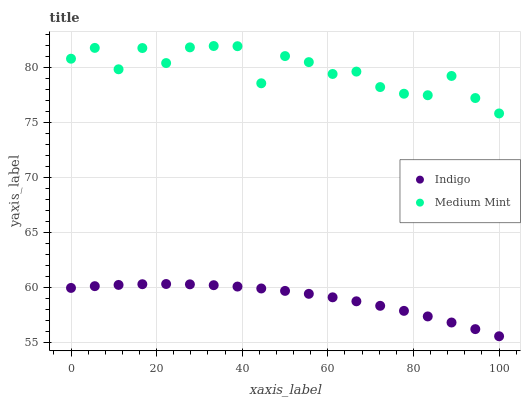Does Indigo have the minimum area under the curve?
Answer yes or no. Yes. Does Medium Mint have the maximum area under the curve?
Answer yes or no. Yes. Does Indigo have the maximum area under the curve?
Answer yes or no. No. Is Indigo the smoothest?
Answer yes or no. Yes. Is Medium Mint the roughest?
Answer yes or no. Yes. Is Indigo the roughest?
Answer yes or no. No. Does Indigo have the lowest value?
Answer yes or no. Yes. Does Medium Mint have the highest value?
Answer yes or no. Yes. Does Indigo have the highest value?
Answer yes or no. No. Is Indigo less than Medium Mint?
Answer yes or no. Yes. Is Medium Mint greater than Indigo?
Answer yes or no. Yes. Does Indigo intersect Medium Mint?
Answer yes or no. No. 